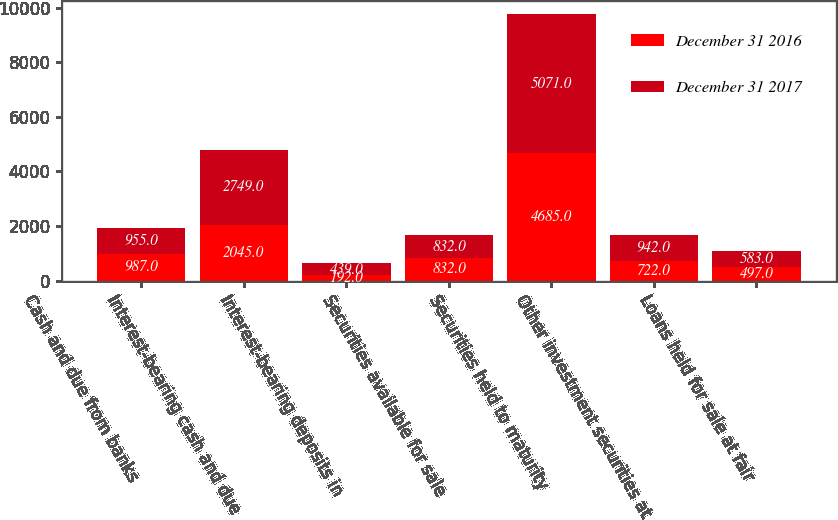Convert chart to OTSL. <chart><loc_0><loc_0><loc_500><loc_500><stacked_bar_chart><ecel><fcel>Cash and due from banks<fcel>Interest-bearing cash and due<fcel>Interest-bearing deposits in<fcel>Securities available for sale<fcel>Securities held to maturity<fcel>Other investment securities at<fcel>Loans held for sale at fair<nl><fcel>December 31 2016<fcel>987<fcel>2045<fcel>192<fcel>832<fcel>4685<fcel>722<fcel>497<nl><fcel>December 31 2017<fcel>955<fcel>2749<fcel>439<fcel>832<fcel>5071<fcel>942<fcel>583<nl></chart> 